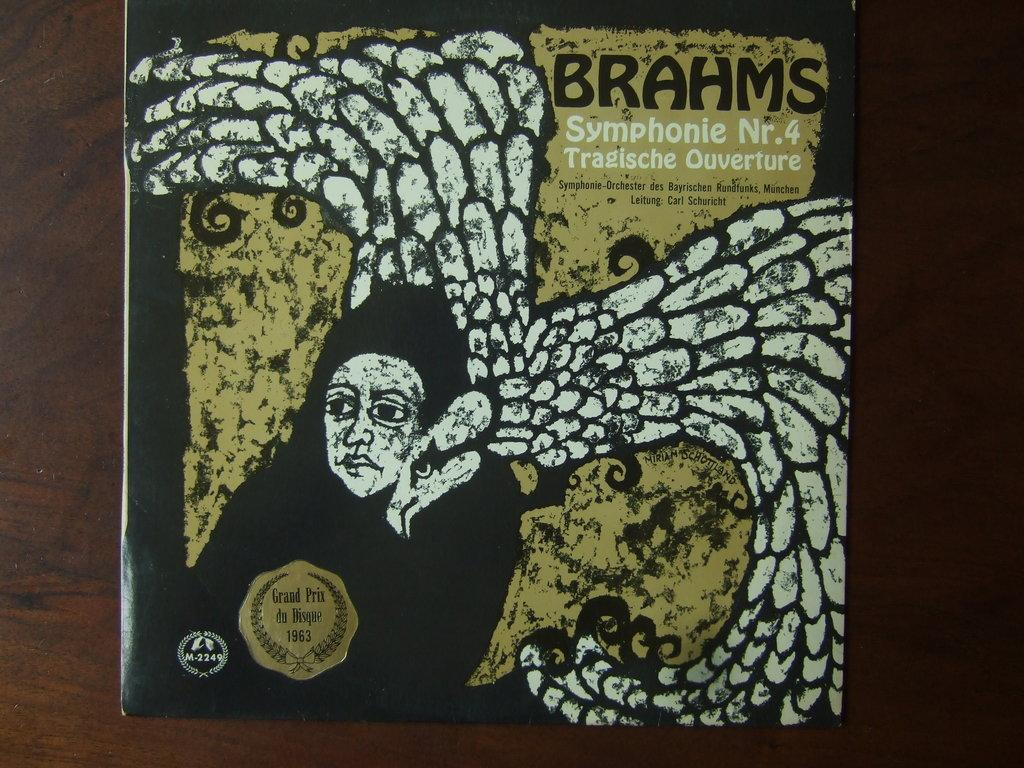What is the main subject of the image? The main subject of the image is a book cover. What can be seen on the book cover? There are pictures and text on the book cover. What type of surface is visible in the background of the image? There is a wooden surface in the background of the image. What is the mass of the sail in the image? There is no sail present in the image; it features a book cover with pictures and text on a wooden surface. 